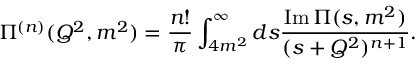<formula> <loc_0><loc_0><loc_500><loc_500>\Pi ^ { ( n ) } ( Q ^ { 2 } , m ^ { 2 } ) = \frac { n ! } { \pi } \int _ { 4 m ^ { 2 } } ^ { \infty } d s \frac { I m \, \Pi ( s , m ^ { 2 } ) } { ( s + Q ^ { 2 } ) ^ { n + 1 } } .</formula> 